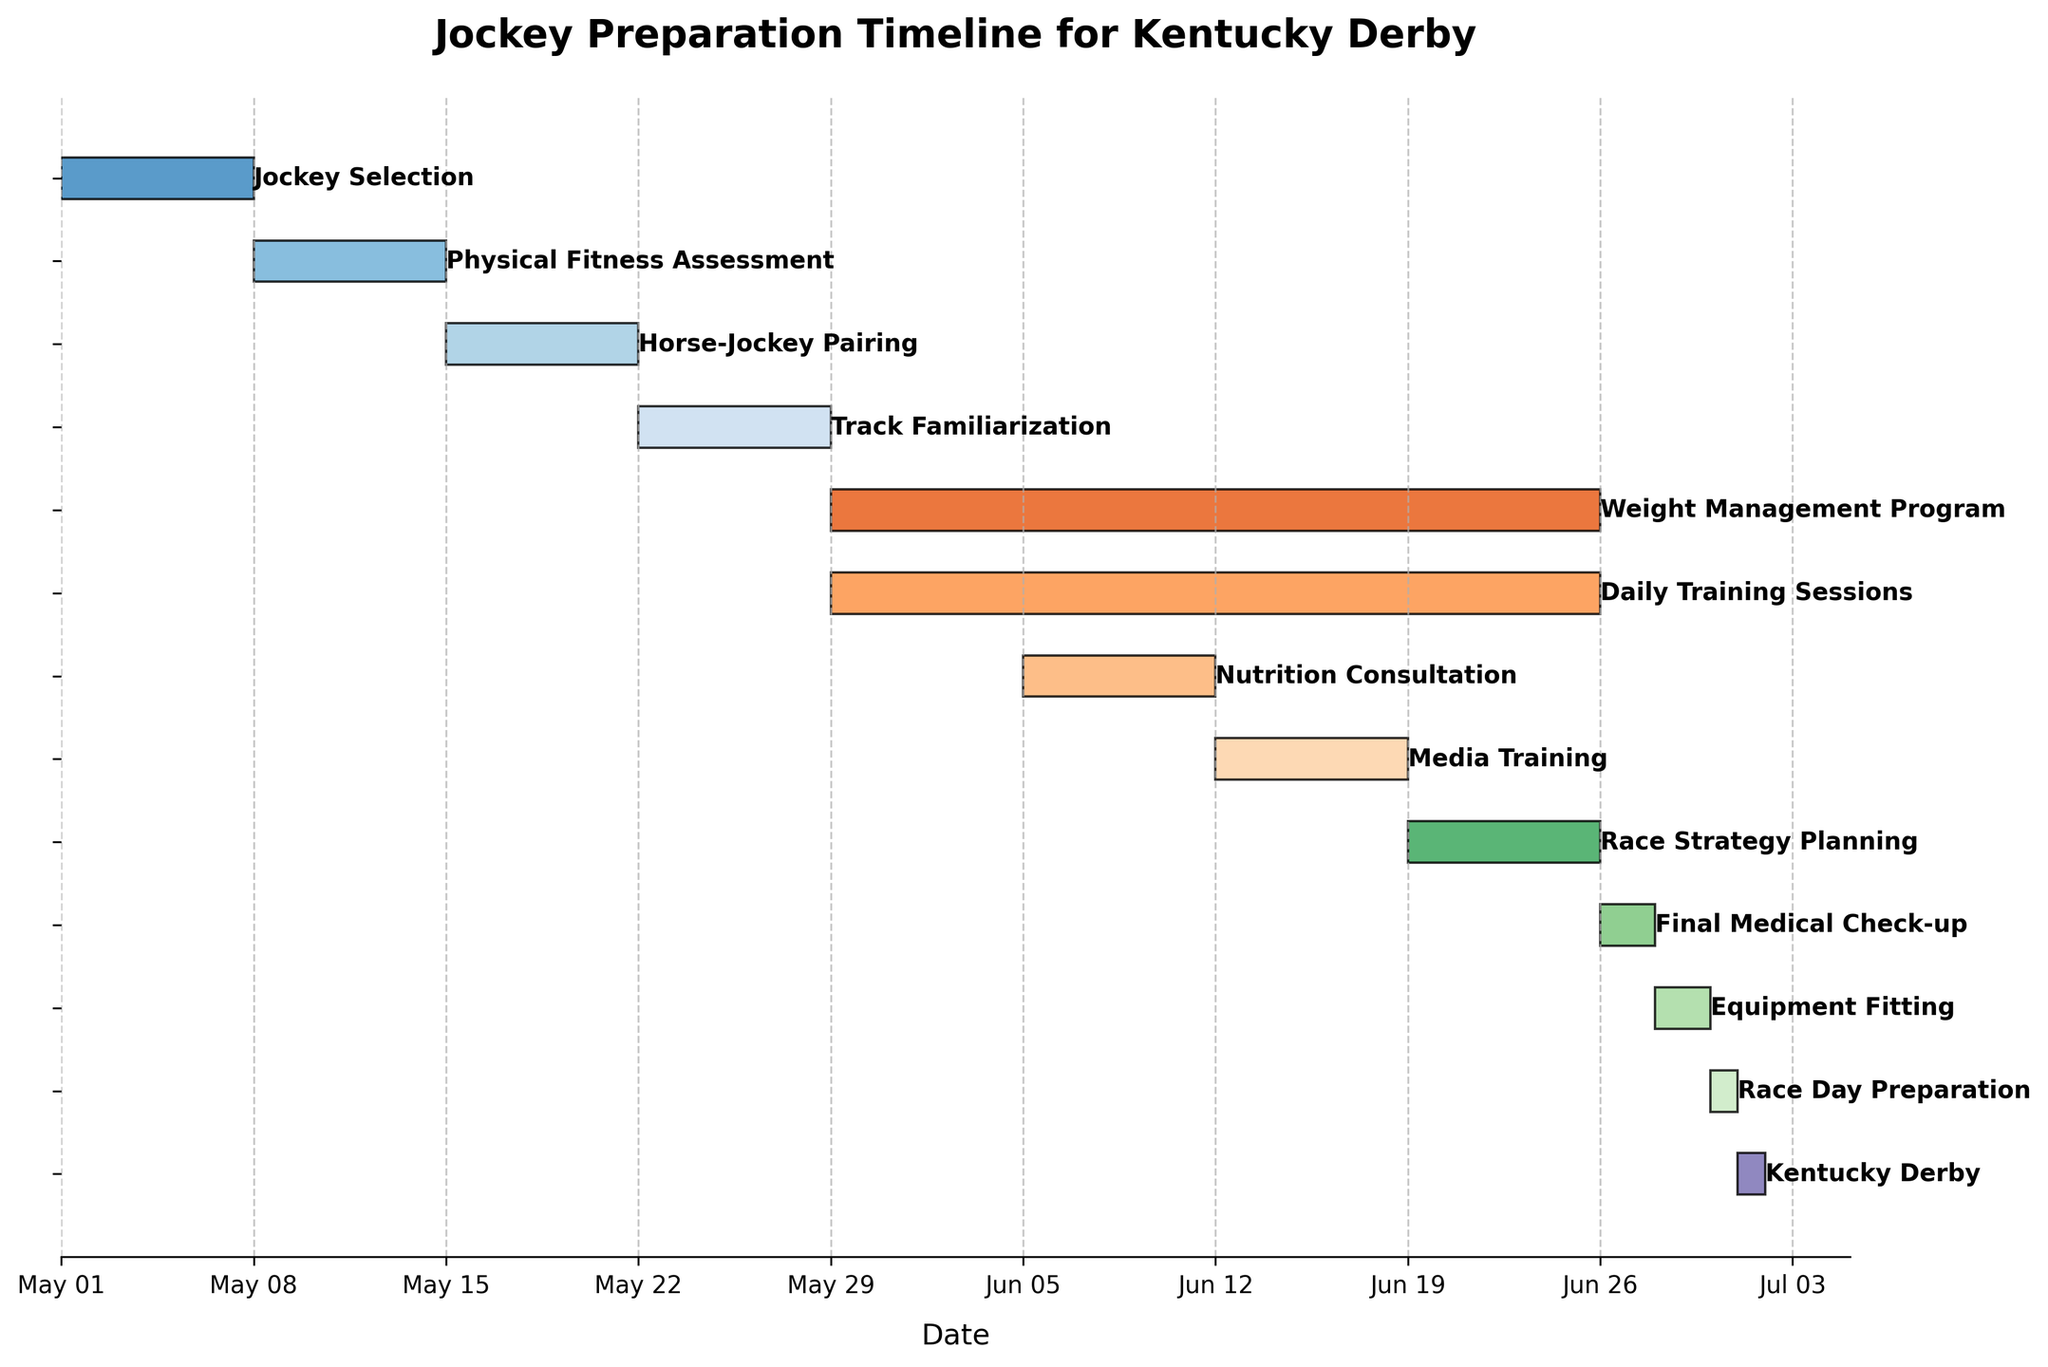What is the title of the Gantt chart? The title is typically displayed at the top of the chart. Here, it provides a summary of what the chart is depicting.
Answer: Jockey Preparation Timeline for Kentucky Derby Over how many days does the Weight Management Program span? By looking at the start date (May 29) and the end date (June 25), you can count the number of days inclusively.
Answer: 28 days Which task ends on the same day the "Daily Training Sessions" begins? By identifying the start date of the "Daily Training Sessions" (May 29) and looking for tasks that end on this date, we can find the "Track Familiarization" task.
Answer: Track Familiarization How many tasks are scheduled to end on June 25? Observing the end dates in the timeline, you can identify and count the tasks that have an end date of June 25, which are "Weight Management Program," "Daily Training Sessions," and "Race Strategy Planning."
Answer: 3 tasks Which tasks overlap with the "Nutrition Consultation"? The "Nutrition Consultation" spans June 5 to June 11. By comparing these dates with other tasks, the overlapping tasks are "Weight Management Program" and "Daily Training Sessions."
Answer: Weight Management Program, Daily Training Sessions What is the total duration from "Jockey Selection" to "Kentucky Derby"? Calculate the number of days from the start of "Jockey Selection" (May 1) to the end of "Kentucky Derby" (July 1). This spans from May 1 to July 1.
Answer: 62 days Which task requires the least amount of preparation time? Identify the tasks with the shortest duration by comparing the difference between the start and end dates. The task with the shortest duration is "Race Day Preparation," which only spans one day (June 30).
Answer: Race Day Preparation What is the consecutive task after "Final Medical Check-up"? The end date for "Final Medical Check-up" is June 27. The consecutive task starting right after is "Equipment Fitting," which starts on June 28.
Answer: Equipment Fitting How many tasks occur in June? Count the tasks that have start or end dates within June. These tasks are "Weight Management Program," "Daily Training Sessions," "Nutrition Consultation," "Media Training," "Race Strategy Planning," "Final Medical Check-up," "Equipment Fitting," and "Race Day Preparation."
Answer: 8 tasks Which task has the same start and end date? Examine the tasks to find one that starts and ends on the same date. Here, the task "Kentucky Derby" occurs only on one day, July 1.
Answer: Kentucky Derby 